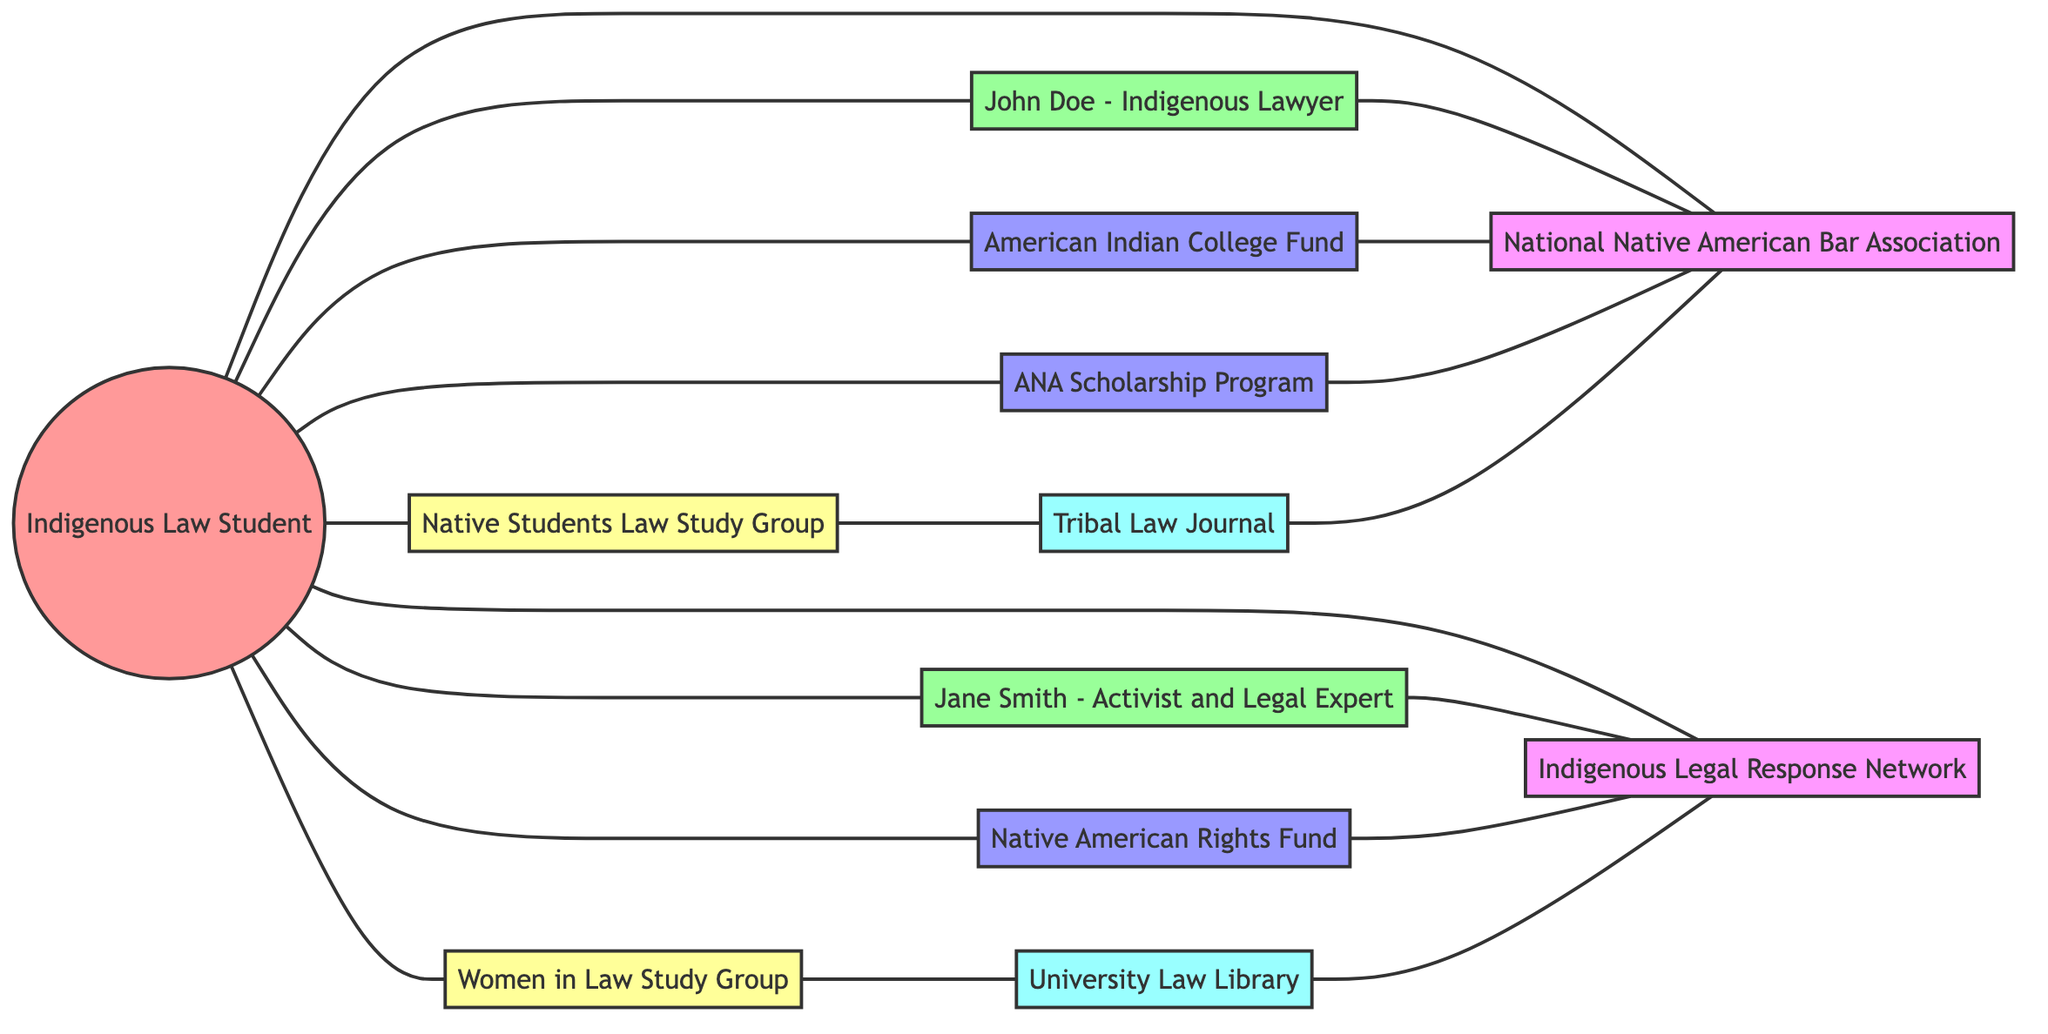What is the total number of nodes in the diagram? The diagram has 12 different nodes representing various entities in the support system for Indigenous law students, such as students, mentors, scholarships, study groups, organizations, and academic resources.
Answer: 12 How many different scholarships are available for the Indigenous law student? There are three scholarships identified in the diagram, which are the American Indian College Fund, Native American Rights Fund, and ANA Scholarship Program.
Answer: 3 Which mentor is linked to the National Native American Bar Association? The mentor John Doe is linked to the National Native American Bar Association, as shown by the edge connecting these two nodes in the diagram.
Answer: John Doe - Indigenous Lawyer What is one academic resource connected to the Native Students Law Study Group? The Tribal Law Journal is connected to the Native Students Law Study Group, indicating a resource that may be utilized by the students in that group.
Answer: Tribal Law Journal Which organization is linked to the Native American Rights Fund? The Native American Rights Fund is connected to the Indigenous Legal Response Network, indicating this organization supports or is associated with the scholarship.
Answer: Indigenous Legal Response Network How many edges are connecting scholarships to organizations? There are four edges connecting the scholarships to their respective organizations in the diagram, indicating the support structures in place.
Answer: 4 What is the relationship between the Women in Law Study Group and the University Law Library? The University Law Library is connected to the Women in Law Study Group, showcasing a resource available to those students.
Answer: connected Name one organization that is associated with both a scholarship and a study group. The National Native American Bar Association is associated with both the American Indian College Fund (scholarship) and the Native Students Law Study Group, illustrating its central role in support networks.
Answer: National Native American Bar Association Which mentor is directly connected to the Indigenous Legal Response Network? Jane Smith, the Activist and Legal Expert, is directly connected to the Indigenous Legal Response Network, as represented by the connecting edge in the diagram.
Answer: Jane Smith - Activist and Legal Expert 